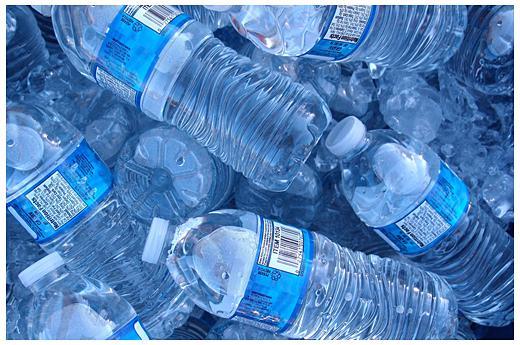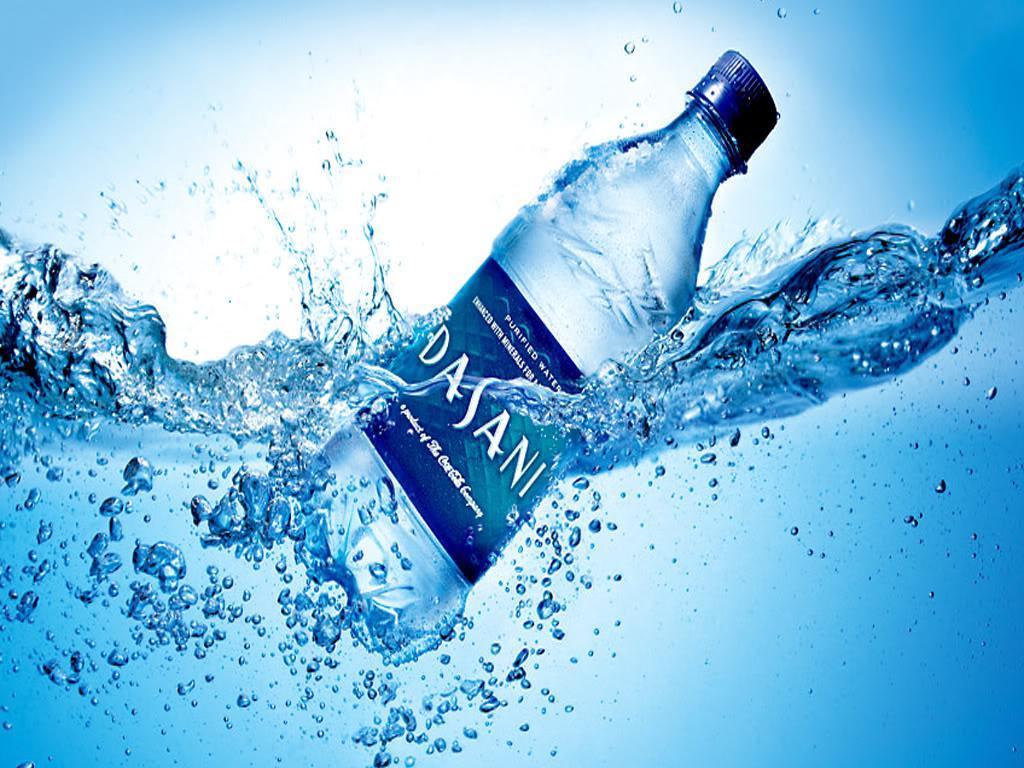The first image is the image on the left, the second image is the image on the right. Assess this claim about the two images: "An image shows water that is not inside a bottle.". Correct or not? Answer yes or no. Yes. 